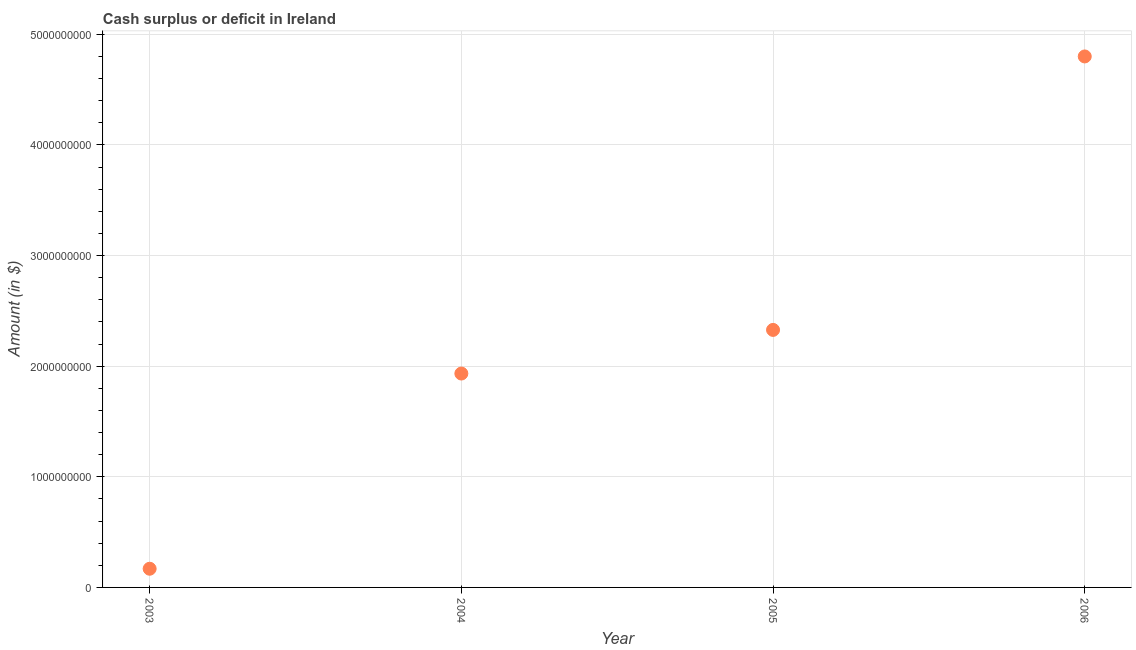What is the cash surplus or deficit in 2003?
Your answer should be compact. 1.69e+08. Across all years, what is the maximum cash surplus or deficit?
Your response must be concise. 4.80e+09. Across all years, what is the minimum cash surplus or deficit?
Give a very brief answer. 1.69e+08. In which year was the cash surplus or deficit maximum?
Ensure brevity in your answer.  2006. In which year was the cash surplus or deficit minimum?
Offer a terse response. 2003. What is the sum of the cash surplus or deficit?
Your response must be concise. 9.23e+09. What is the difference between the cash surplus or deficit in 2003 and 2005?
Your response must be concise. -2.16e+09. What is the average cash surplus or deficit per year?
Your answer should be very brief. 2.31e+09. What is the median cash surplus or deficit?
Offer a very short reply. 2.13e+09. Do a majority of the years between 2003 and 2004 (inclusive) have cash surplus or deficit greater than 3000000000 $?
Your answer should be compact. No. What is the ratio of the cash surplus or deficit in 2005 to that in 2006?
Give a very brief answer. 0.48. Is the cash surplus or deficit in 2003 less than that in 2006?
Offer a terse response. Yes. What is the difference between the highest and the second highest cash surplus or deficit?
Your answer should be compact. 2.47e+09. Is the sum of the cash surplus or deficit in 2005 and 2006 greater than the maximum cash surplus or deficit across all years?
Offer a very short reply. Yes. What is the difference between the highest and the lowest cash surplus or deficit?
Offer a very short reply. 4.63e+09. In how many years, is the cash surplus or deficit greater than the average cash surplus or deficit taken over all years?
Your answer should be very brief. 2. Does the graph contain grids?
Your answer should be compact. Yes. What is the title of the graph?
Make the answer very short. Cash surplus or deficit in Ireland. What is the label or title of the X-axis?
Keep it short and to the point. Year. What is the label or title of the Y-axis?
Provide a succinct answer. Amount (in $). What is the Amount (in $) in 2003?
Provide a short and direct response. 1.69e+08. What is the Amount (in $) in 2004?
Your answer should be very brief. 1.93e+09. What is the Amount (in $) in 2005?
Your response must be concise. 2.33e+09. What is the Amount (in $) in 2006?
Ensure brevity in your answer.  4.80e+09. What is the difference between the Amount (in $) in 2003 and 2004?
Provide a succinct answer. -1.76e+09. What is the difference between the Amount (in $) in 2003 and 2005?
Make the answer very short. -2.16e+09. What is the difference between the Amount (in $) in 2003 and 2006?
Your answer should be very brief. -4.63e+09. What is the difference between the Amount (in $) in 2004 and 2005?
Provide a short and direct response. -3.94e+08. What is the difference between the Amount (in $) in 2004 and 2006?
Make the answer very short. -2.87e+09. What is the difference between the Amount (in $) in 2005 and 2006?
Your answer should be very brief. -2.47e+09. What is the ratio of the Amount (in $) in 2003 to that in 2004?
Make the answer very short. 0.09. What is the ratio of the Amount (in $) in 2003 to that in 2005?
Ensure brevity in your answer.  0.07. What is the ratio of the Amount (in $) in 2003 to that in 2006?
Your answer should be very brief. 0.04. What is the ratio of the Amount (in $) in 2004 to that in 2005?
Offer a very short reply. 0.83. What is the ratio of the Amount (in $) in 2004 to that in 2006?
Your response must be concise. 0.4. What is the ratio of the Amount (in $) in 2005 to that in 2006?
Provide a succinct answer. 0.48. 